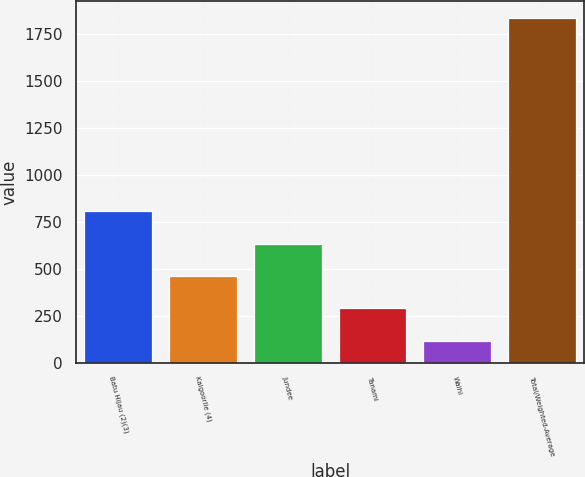Convert chart to OTSL. <chart><loc_0><loc_0><loc_500><loc_500><bar_chart><fcel>Batu Hijau (2)(3)<fcel>Kalgoorlie (4)<fcel>Jundee<fcel>Tanami<fcel>Waihi<fcel>Total/Weighted-Average<nl><fcel>804.7<fcel>460.9<fcel>632.8<fcel>289<fcel>113<fcel>1832<nl></chart> 